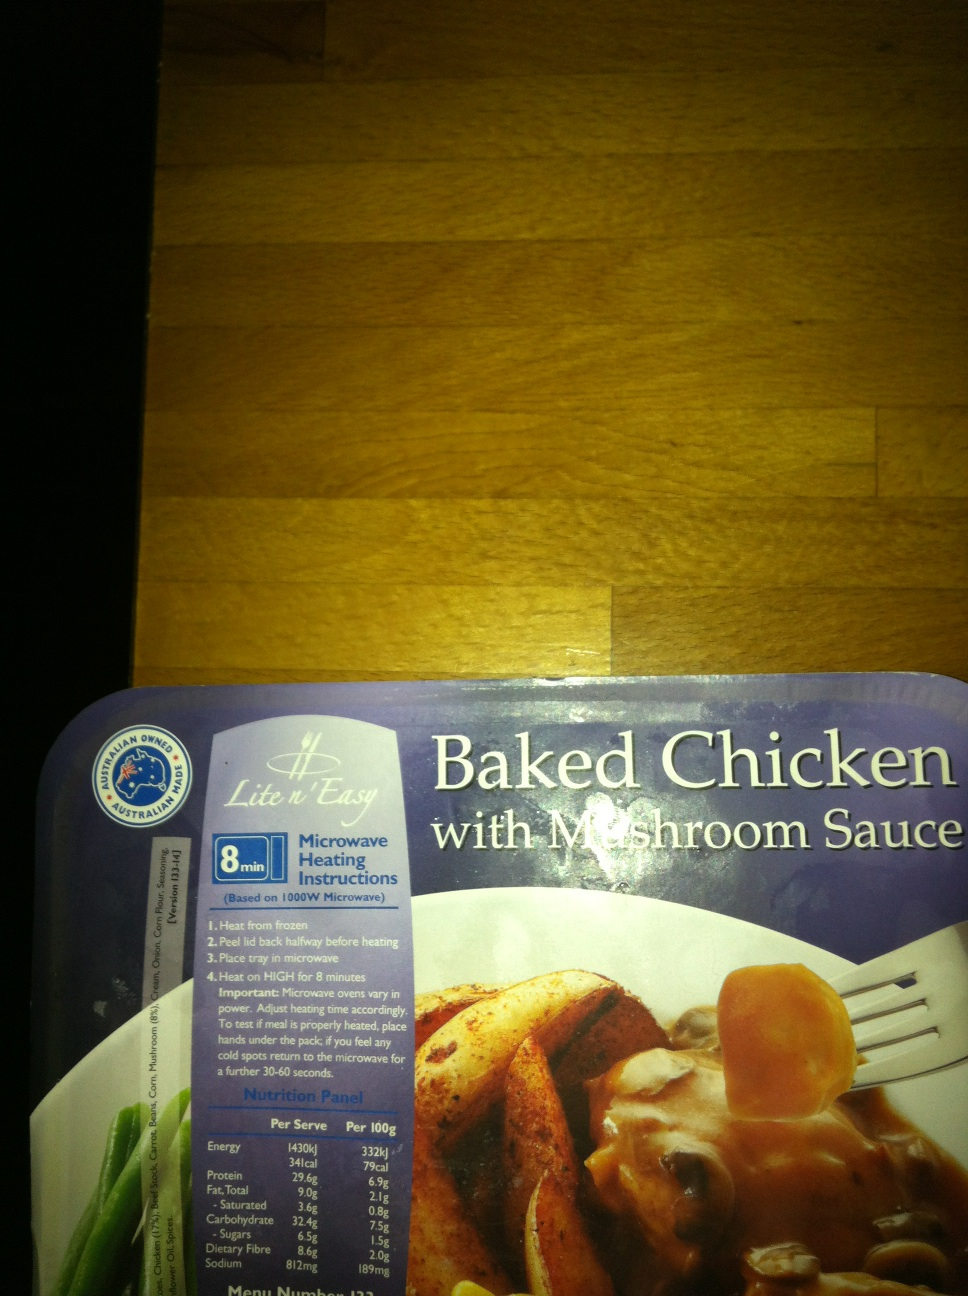How nutritious is this meal according to the nutrition panel? According to the nutrition panel, each 100g serving provides roughly 1430kJ of energy, equivalent to about 341 calories. It contains 9.2g of protein, 6.2g of fat of which 2.9g is saturated, 34.2g of carbohydrates, and 7.5g of sugars, alongside 1.5g of dietary fiber and 819mg of sodium. This positions the meal as a reasonable option in terms of calorie count and nutrient content, emphasizing moderate protein and potential high sodium. 